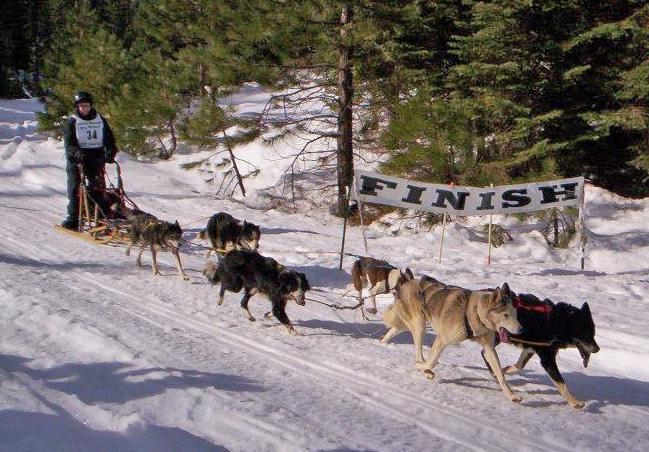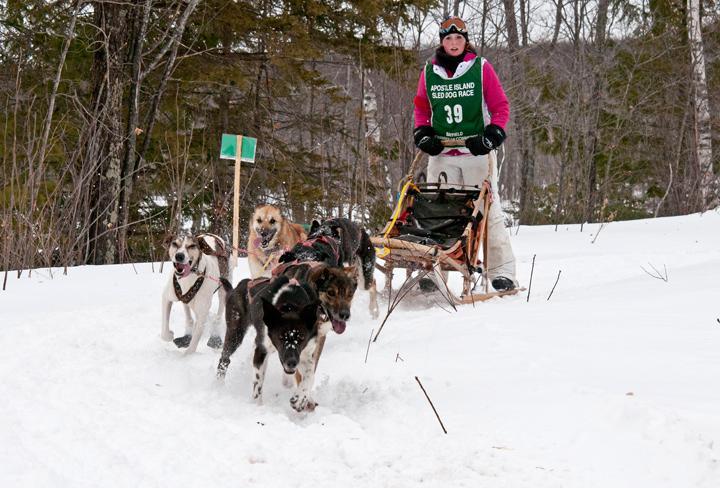The first image is the image on the left, the second image is the image on the right. Examine the images to the left and right. Is the description "In the left image, two dogs are pulling a sled on the snow with a rope extending to the left." accurate? Answer yes or no. No. 